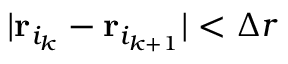Convert formula to latex. <formula><loc_0><loc_0><loc_500><loc_500>| { r } _ { i _ { k } } - { r } _ { i _ { k + 1 } } | < \Delta r</formula> 